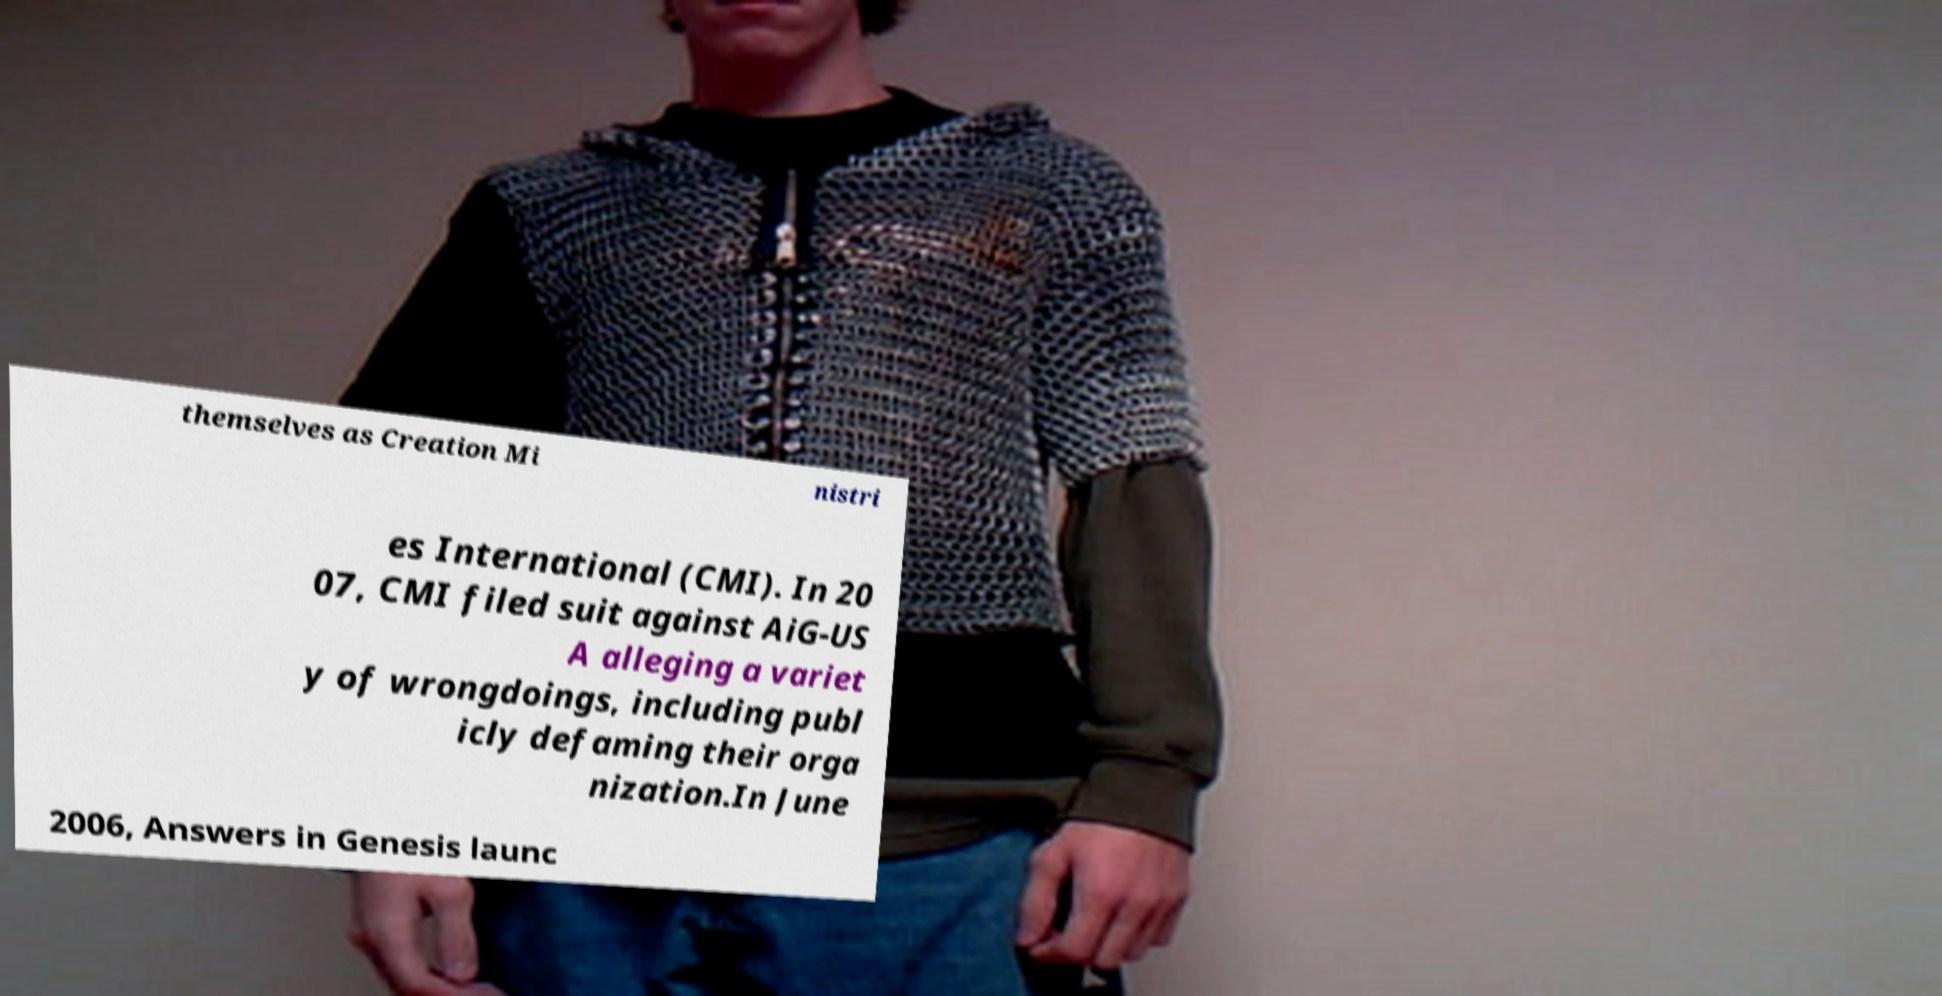Can you accurately transcribe the text from the provided image for me? themselves as Creation Mi nistri es International (CMI). In 20 07, CMI filed suit against AiG-US A alleging a variet y of wrongdoings, including publ icly defaming their orga nization.In June 2006, Answers in Genesis launc 